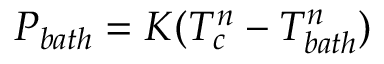<formula> <loc_0><loc_0><loc_500><loc_500>P _ { b a t h } = K ( T _ { c } ^ { n } - T _ { b a t h } ^ { n } )</formula> 